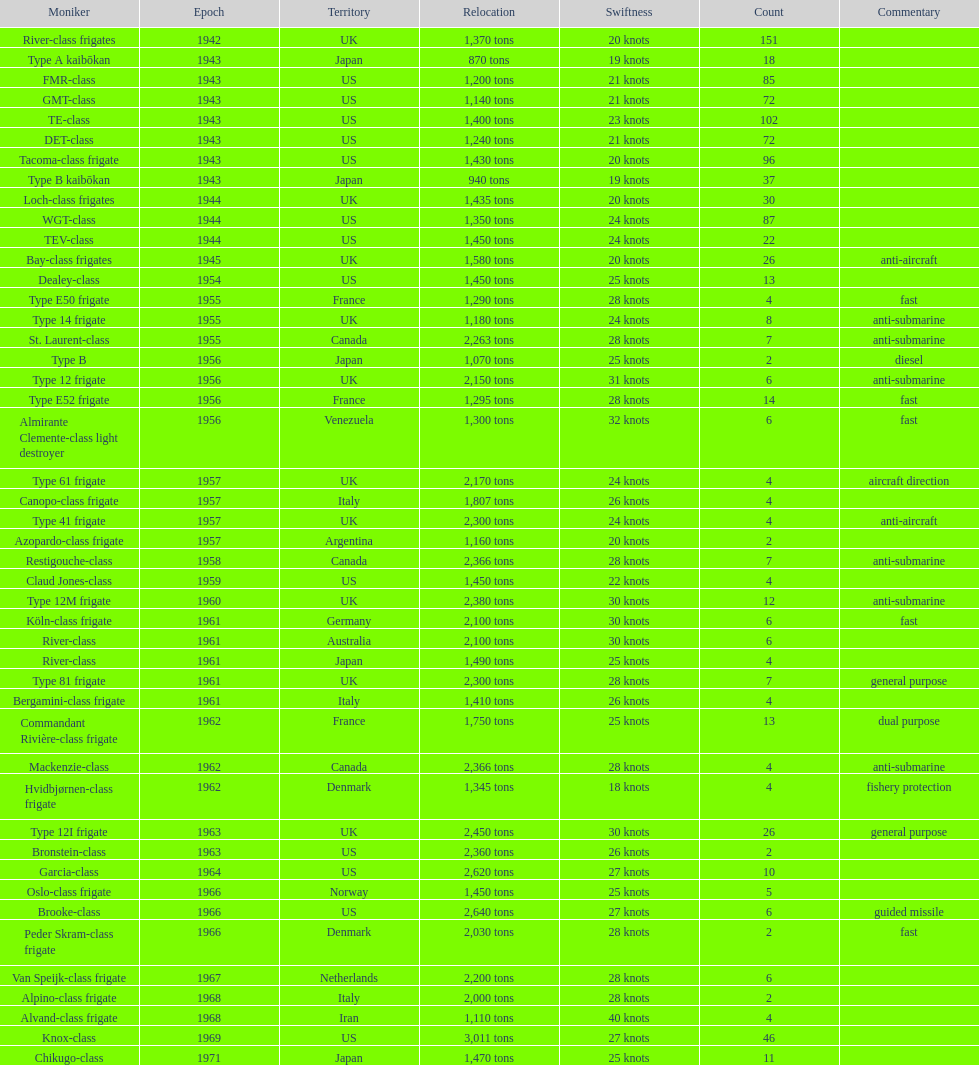What is the top speed? 40 knots. 